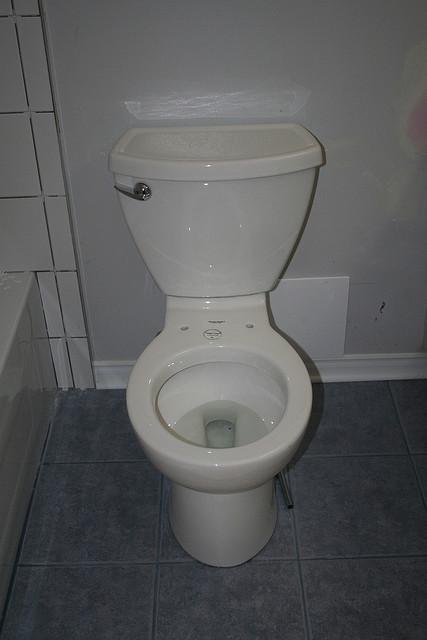Is the toilet still in good condition?
Short answer required. Yes. What company is written on the top of the commode?
Keep it brief. Unknown. Does the floor look clean?
Concise answer only. Yes. Does the bottom of the toilet cover only one flooring tile?
Answer briefly. No. What is the color of the floor?
Answer briefly. Gray. Is there a toilet brush next to the toilet?
Short answer required. No. Is this toilet indoors?
Short answer required. Yes. How many toilets in the picture?
Concise answer only. 1. What is the use of this item?
Give a very brief answer. Go to bathroom. Is the flushing mechanism visible?
Quick response, please. Yes. Does the bathroom need fixing?
Keep it brief. No. Is this usable?
Quick response, please. Yes. What style of toilet is this?
Keep it brief. Modern. What is missing from the toilet?
Give a very brief answer. Seat. 